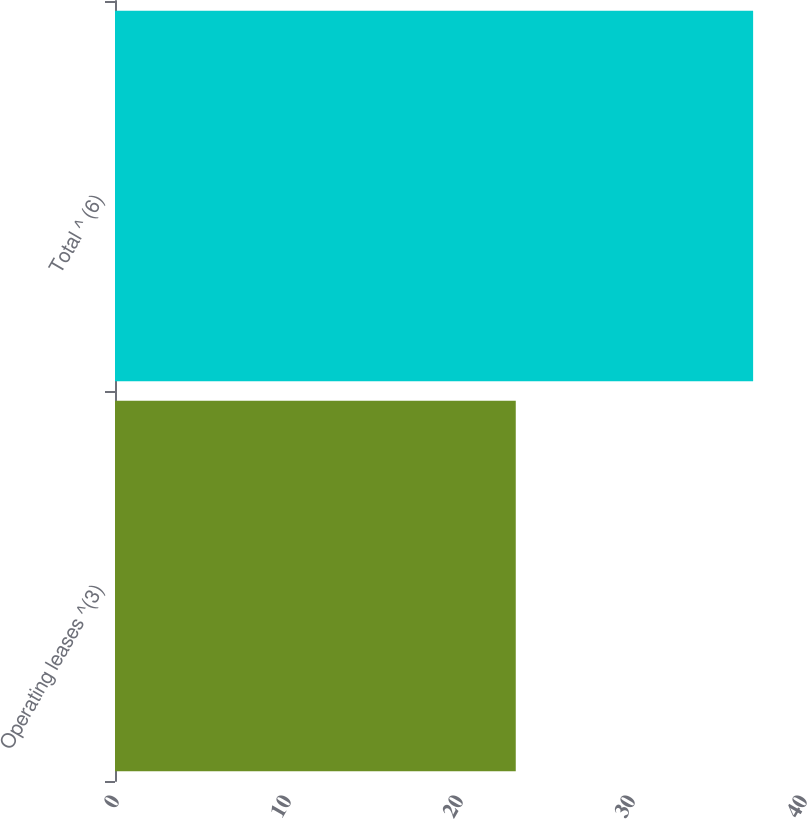Convert chart to OTSL. <chart><loc_0><loc_0><loc_500><loc_500><bar_chart><fcel>Operating leases ^(3)<fcel>Total ^ (6)<nl><fcel>23.3<fcel>37.1<nl></chart> 